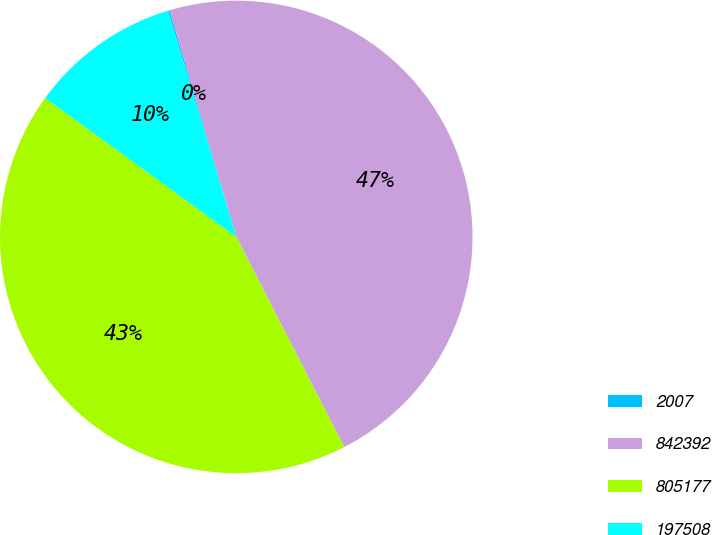Convert chart. <chart><loc_0><loc_0><loc_500><loc_500><pie_chart><fcel>2007<fcel>842392<fcel>805177<fcel>197508<nl><fcel>0.11%<fcel>47.01%<fcel>42.55%<fcel>10.33%<nl></chart> 